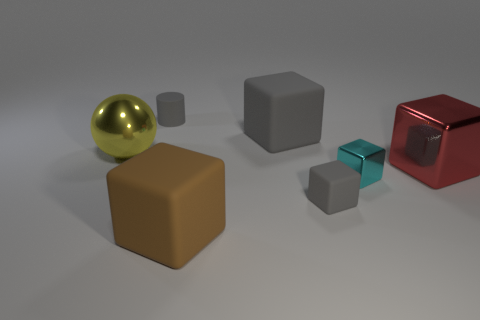There is a tiny matte block; is it the same color as the small matte object that is behind the tiny metal cube?
Provide a succinct answer. Yes. There is a small matte object in front of the red shiny object; does it have the same color as the small thing behind the large gray object?
Your answer should be very brief. Yes. The other gray matte thing that is the same shape as the large gray matte thing is what size?
Offer a terse response. Small. Is the number of balls greater than the number of gray cubes?
Provide a succinct answer. No. Do the big red object and the cyan metallic thing have the same shape?
Offer a terse response. Yes. What is the big object that is on the left side of the tiny matte thing that is behind the big red object made of?
Provide a short and direct response. Metal. What material is the big thing that is the same color as the tiny cylinder?
Give a very brief answer. Rubber. Is the cyan object the same size as the cylinder?
Provide a short and direct response. Yes. There is a big block that is to the right of the small cyan metallic thing; is there a large brown rubber block in front of it?
Keep it short and to the point. Yes. There is a rubber cylinder that is the same color as the tiny rubber block; what size is it?
Provide a short and direct response. Small. 